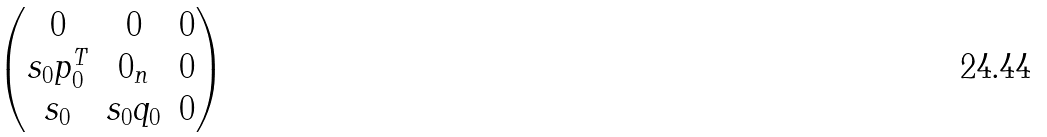Convert formula to latex. <formula><loc_0><loc_0><loc_500><loc_500>\begin{pmatrix} 0 & 0 & 0 \\ s _ { 0 } p _ { 0 } ^ { T } & 0 _ { n } & 0 \\ s _ { 0 } & s _ { 0 } q _ { 0 } & 0 \end{pmatrix}</formula> 